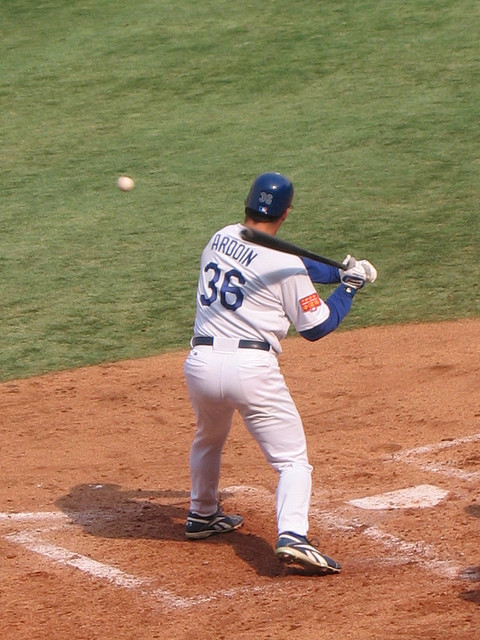Read all the text in this image. 36 AROOIN 36 